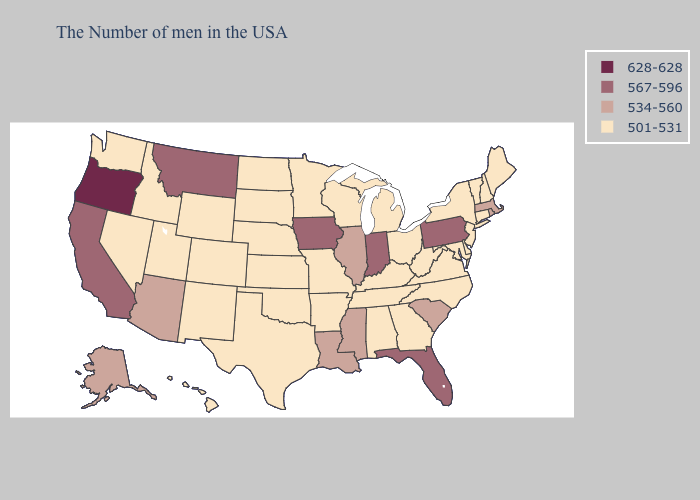Is the legend a continuous bar?
Concise answer only. No. Name the states that have a value in the range 628-628?
Answer briefly. Oregon. What is the value of South Dakota?
Keep it brief. 501-531. Does Virginia have a lower value than Alabama?
Concise answer only. No. What is the lowest value in states that border Louisiana?
Quick response, please. 501-531. Which states have the lowest value in the Northeast?
Keep it brief. Maine, New Hampshire, Vermont, Connecticut, New York, New Jersey. What is the highest value in states that border New Jersey?
Short answer required. 567-596. What is the value of Michigan?
Keep it brief. 501-531. What is the value of Connecticut?
Be succinct. 501-531. Name the states that have a value in the range 567-596?
Be succinct. Pennsylvania, Florida, Indiana, Iowa, Montana, California. Does Oregon have the highest value in the West?
Concise answer only. Yes. Name the states that have a value in the range 628-628?
Write a very short answer. Oregon. Among the states that border Maryland , which have the highest value?
Keep it brief. Pennsylvania. Name the states that have a value in the range 628-628?
Give a very brief answer. Oregon. How many symbols are there in the legend?
Short answer required. 4. 